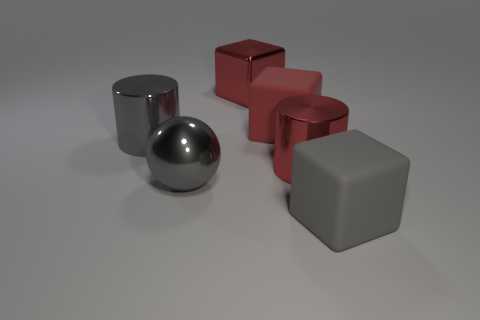The shiny cylinder that is the same color as the shiny sphere is what size?
Provide a short and direct response. Large. How many matte things are large spheres or tiny brown cylinders?
Offer a very short reply. 0. There is a big thing that is left of the large red matte thing and right of the gray metal ball; what is its material?
Offer a very short reply. Metal. Are there any rubber blocks that are in front of the big metal object that is to the right of the big rubber object left of the gray matte block?
Ensure brevity in your answer.  Yes. Are there any other things that are made of the same material as the big gray ball?
Offer a terse response. Yes. The object that is made of the same material as the big gray block is what shape?
Your answer should be very brief. Cube. Is the number of balls in front of the big shiny ball less than the number of big red matte things that are on the right side of the gray matte cube?
Offer a terse response. No. What number of big things are either red metallic objects or red rubber things?
Offer a very short reply. 3. Does the thing that is behind the red rubber object have the same shape as the object that is in front of the big gray metallic sphere?
Make the answer very short. Yes. What is the size of the block that is left of the rubber thing behind the gray matte block in front of the big gray sphere?
Give a very brief answer. Large. 